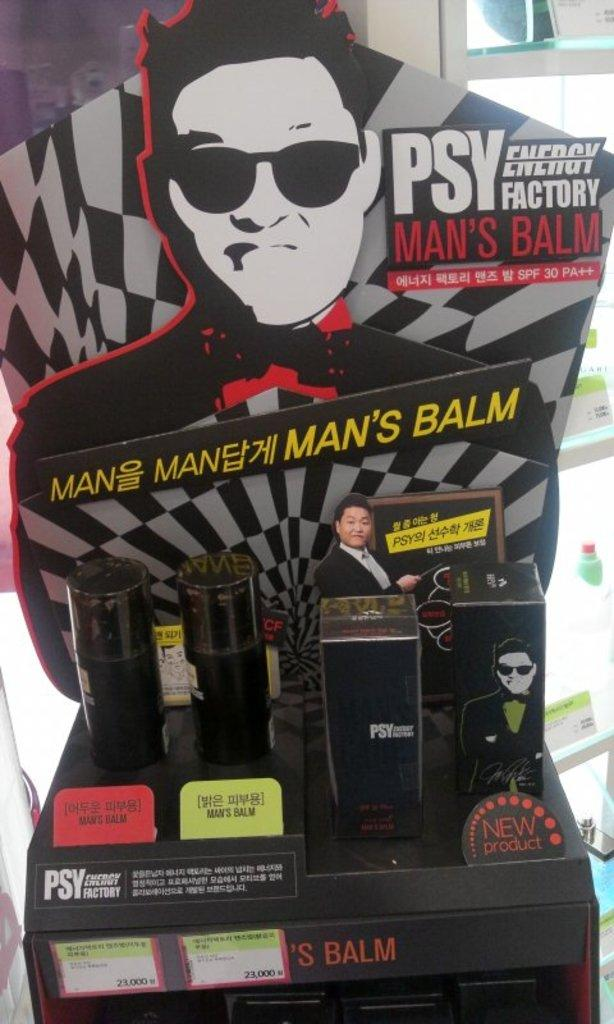Provide a one-sentence caption for the provided image. A display with Psy Man's Balm products on it. 